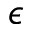<formula> <loc_0><loc_0><loc_500><loc_500>\epsilon</formula> 